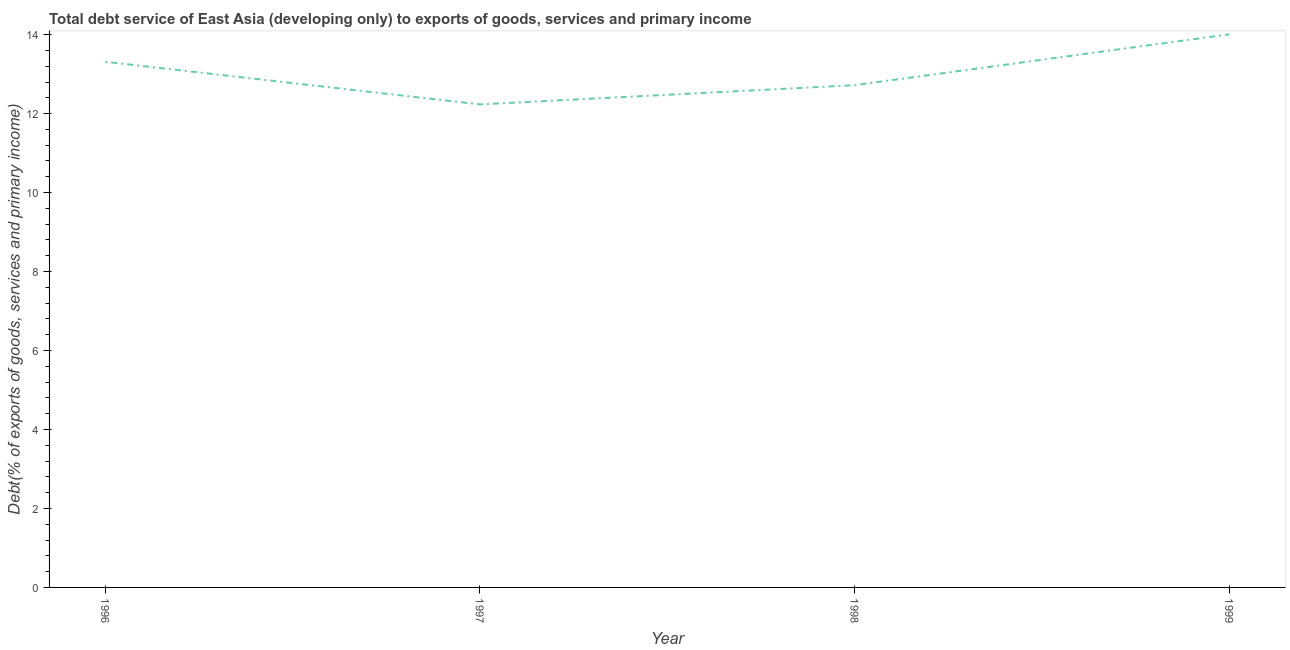What is the total debt service in 1999?
Ensure brevity in your answer.  14.01. Across all years, what is the maximum total debt service?
Make the answer very short. 14.01. Across all years, what is the minimum total debt service?
Offer a terse response. 12.23. In which year was the total debt service maximum?
Offer a terse response. 1999. In which year was the total debt service minimum?
Provide a short and direct response. 1997. What is the sum of the total debt service?
Your answer should be very brief. 52.27. What is the difference between the total debt service in 1997 and 1998?
Provide a short and direct response. -0.49. What is the average total debt service per year?
Make the answer very short. 13.07. What is the median total debt service?
Offer a terse response. 13.02. In how many years, is the total debt service greater than 10.4 %?
Provide a short and direct response. 4. Do a majority of the years between 1998 and 1999 (inclusive) have total debt service greater than 10.4 %?
Your response must be concise. Yes. What is the ratio of the total debt service in 1997 to that in 1999?
Keep it short and to the point. 0.87. Is the difference between the total debt service in 1997 and 1999 greater than the difference between any two years?
Provide a succinct answer. Yes. What is the difference between the highest and the second highest total debt service?
Make the answer very short. 0.7. Is the sum of the total debt service in 1996 and 1998 greater than the maximum total debt service across all years?
Your answer should be very brief. Yes. What is the difference between the highest and the lowest total debt service?
Your response must be concise. 1.77. Does the total debt service monotonically increase over the years?
Provide a short and direct response. No. How many lines are there?
Make the answer very short. 1. What is the difference between two consecutive major ticks on the Y-axis?
Provide a succinct answer. 2. Does the graph contain grids?
Offer a terse response. No. What is the title of the graph?
Offer a very short reply. Total debt service of East Asia (developing only) to exports of goods, services and primary income. What is the label or title of the Y-axis?
Keep it short and to the point. Debt(% of exports of goods, services and primary income). What is the Debt(% of exports of goods, services and primary income) in 1996?
Your response must be concise. 13.31. What is the Debt(% of exports of goods, services and primary income) in 1997?
Ensure brevity in your answer.  12.23. What is the Debt(% of exports of goods, services and primary income) in 1998?
Provide a succinct answer. 12.72. What is the Debt(% of exports of goods, services and primary income) in 1999?
Your answer should be compact. 14.01. What is the difference between the Debt(% of exports of goods, services and primary income) in 1996 and 1997?
Your response must be concise. 1.08. What is the difference between the Debt(% of exports of goods, services and primary income) in 1996 and 1998?
Provide a short and direct response. 0.59. What is the difference between the Debt(% of exports of goods, services and primary income) in 1996 and 1999?
Provide a short and direct response. -0.7. What is the difference between the Debt(% of exports of goods, services and primary income) in 1997 and 1998?
Give a very brief answer. -0.49. What is the difference between the Debt(% of exports of goods, services and primary income) in 1997 and 1999?
Provide a succinct answer. -1.77. What is the difference between the Debt(% of exports of goods, services and primary income) in 1998 and 1999?
Your answer should be compact. -1.29. What is the ratio of the Debt(% of exports of goods, services and primary income) in 1996 to that in 1997?
Give a very brief answer. 1.09. What is the ratio of the Debt(% of exports of goods, services and primary income) in 1996 to that in 1998?
Your answer should be very brief. 1.05. What is the ratio of the Debt(% of exports of goods, services and primary income) in 1996 to that in 1999?
Provide a short and direct response. 0.95. What is the ratio of the Debt(% of exports of goods, services and primary income) in 1997 to that in 1998?
Your response must be concise. 0.96. What is the ratio of the Debt(% of exports of goods, services and primary income) in 1997 to that in 1999?
Offer a very short reply. 0.87. What is the ratio of the Debt(% of exports of goods, services and primary income) in 1998 to that in 1999?
Offer a very short reply. 0.91. 